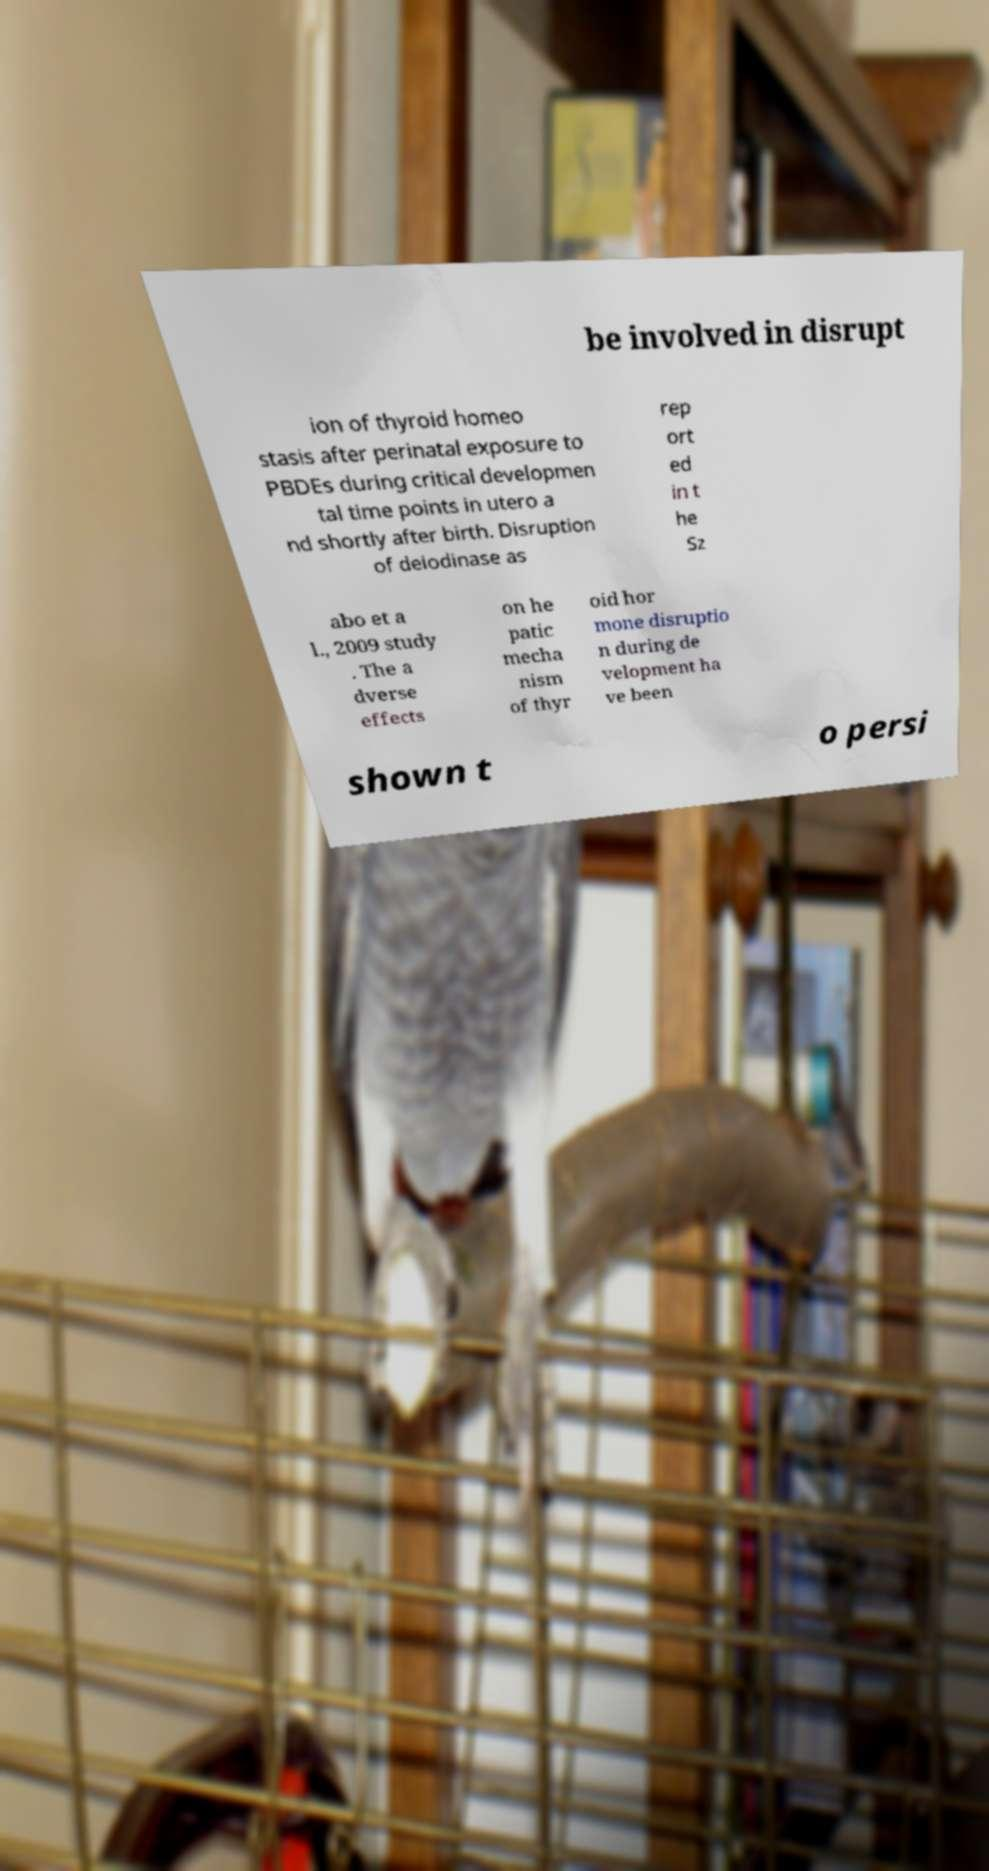For documentation purposes, I need the text within this image transcribed. Could you provide that? be involved in disrupt ion of thyroid homeo stasis after perinatal exposure to PBDEs during critical developmen tal time points in utero a nd shortly after birth. Disruption of deiodinase as rep ort ed in t he Sz abo et a l., 2009 study . The a dverse effects on he patic mecha nism of thyr oid hor mone disruptio n during de velopment ha ve been shown t o persi 